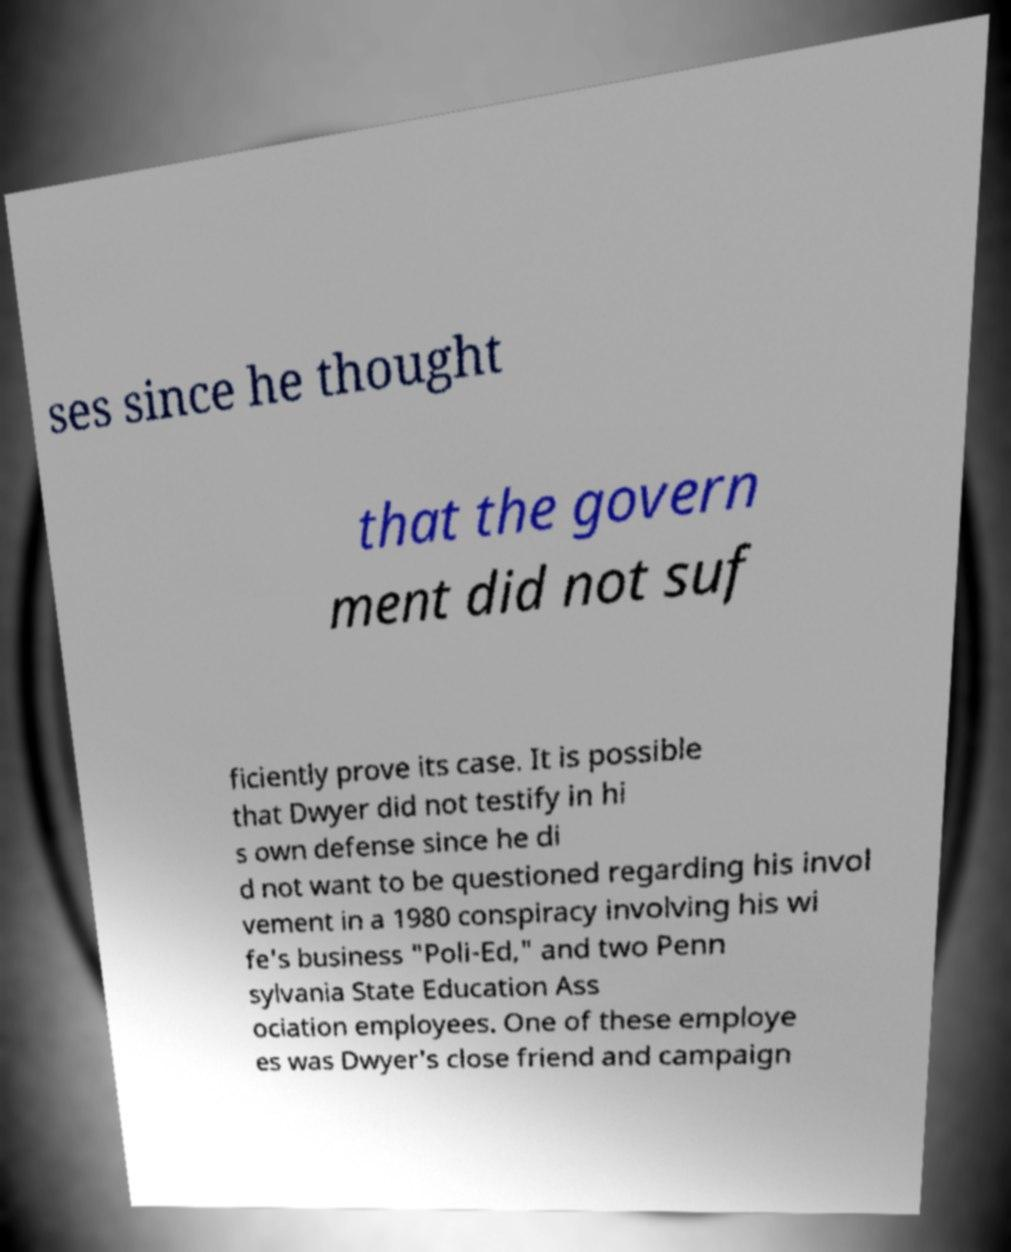Could you extract and type out the text from this image? ses since he thought that the govern ment did not suf ficiently prove its case. It is possible that Dwyer did not testify in hi s own defense since he di d not want to be questioned regarding his invol vement in a 1980 conspiracy involving his wi fe's business "Poli-Ed," and two Penn sylvania State Education Ass ociation employees. One of these employe es was Dwyer's close friend and campaign 